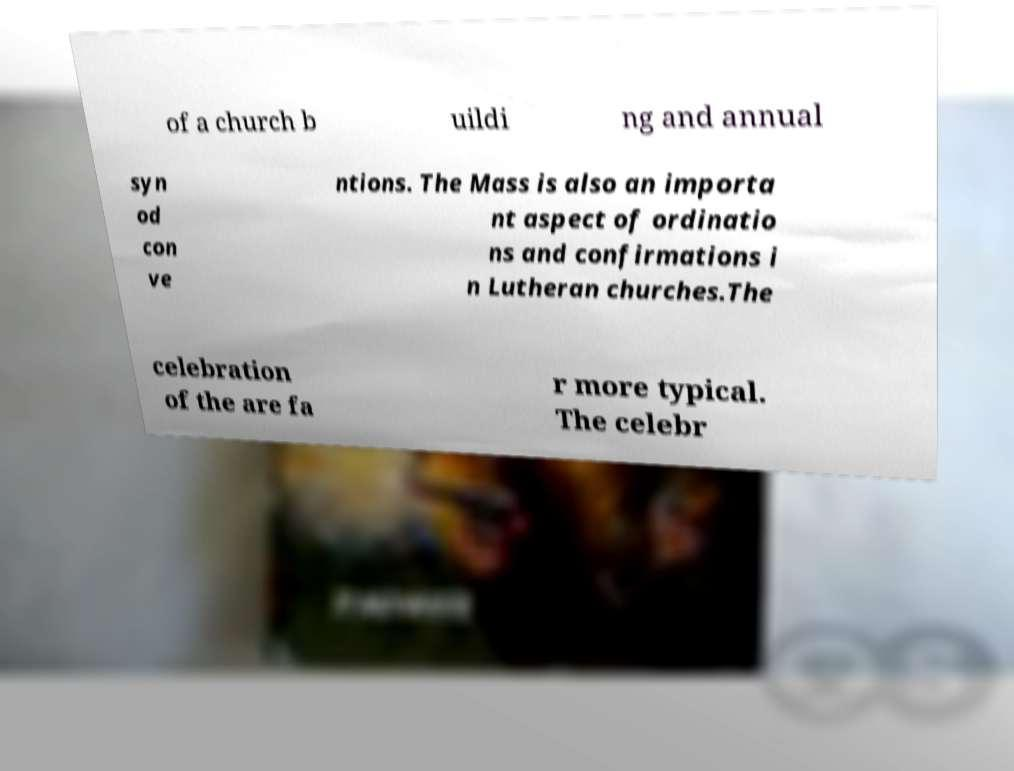Can you read and provide the text displayed in the image?This photo seems to have some interesting text. Can you extract and type it out for me? of a church b uildi ng and annual syn od con ve ntions. The Mass is also an importa nt aspect of ordinatio ns and confirmations i n Lutheran churches.The celebration of the are fa r more typical. The celebr 